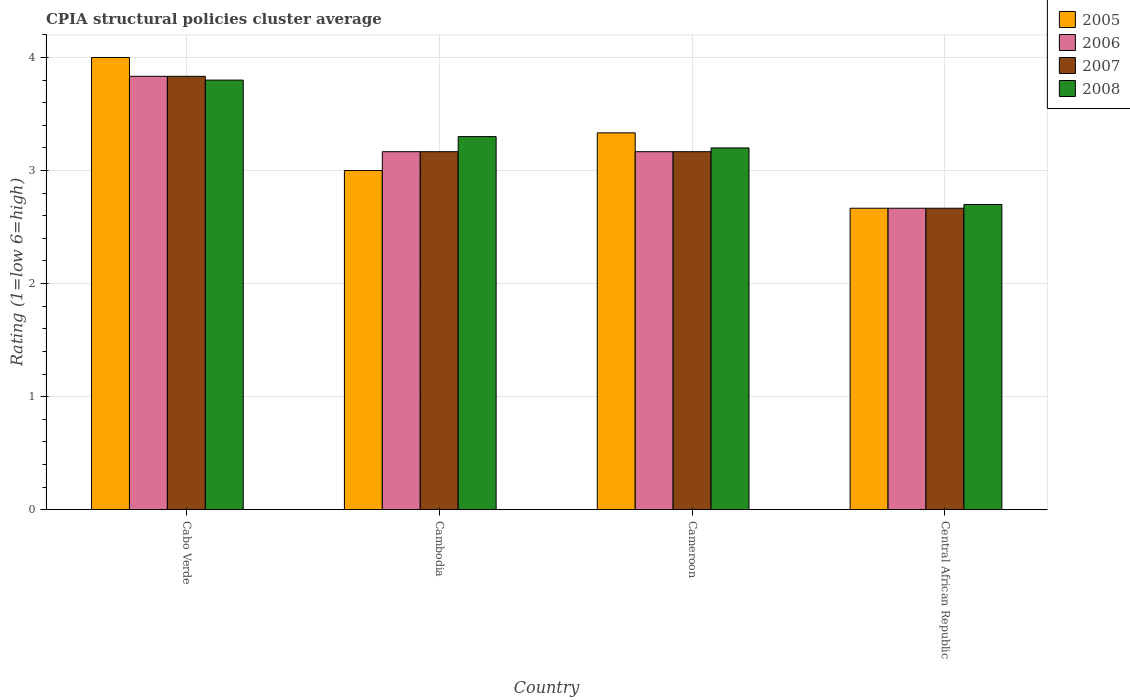Are the number of bars on each tick of the X-axis equal?
Keep it short and to the point. Yes. How many bars are there on the 4th tick from the left?
Give a very brief answer. 4. What is the label of the 3rd group of bars from the left?
Provide a short and direct response. Cameroon. In how many cases, is the number of bars for a given country not equal to the number of legend labels?
Your answer should be compact. 0. What is the CPIA rating in 2005 in Cameroon?
Your response must be concise. 3.33. Across all countries, what is the maximum CPIA rating in 2006?
Provide a succinct answer. 3.83. Across all countries, what is the minimum CPIA rating in 2007?
Give a very brief answer. 2.67. In which country was the CPIA rating in 2008 maximum?
Your response must be concise. Cabo Verde. In which country was the CPIA rating in 2008 minimum?
Make the answer very short. Central African Republic. What is the total CPIA rating in 2008 in the graph?
Your answer should be very brief. 13. What is the difference between the CPIA rating in 2005 in Central African Republic and the CPIA rating in 2006 in Cameroon?
Your answer should be compact. -0.5. What is the average CPIA rating in 2006 per country?
Offer a very short reply. 3.21. What is the difference between the CPIA rating of/in 2005 and CPIA rating of/in 2008 in Cameroon?
Your response must be concise. 0.13. In how many countries, is the CPIA rating in 2008 greater than 3.4?
Your answer should be very brief. 1. What is the ratio of the CPIA rating in 2006 in Cabo Verde to that in Cameroon?
Your response must be concise. 1.21. Is the CPIA rating in 2006 in Cabo Verde less than that in Cameroon?
Provide a short and direct response. No. Is the difference between the CPIA rating in 2005 in Cabo Verde and Cambodia greater than the difference between the CPIA rating in 2008 in Cabo Verde and Cambodia?
Your answer should be compact. Yes. What is the difference between the highest and the second highest CPIA rating in 2007?
Provide a short and direct response. -0.67. What is the difference between the highest and the lowest CPIA rating in 2008?
Keep it short and to the point. 1.1. Is the sum of the CPIA rating in 2006 in Cameroon and Central African Republic greater than the maximum CPIA rating in 2007 across all countries?
Your answer should be very brief. Yes. Is it the case that in every country, the sum of the CPIA rating in 2008 and CPIA rating in 2007 is greater than the sum of CPIA rating in 2005 and CPIA rating in 2006?
Your answer should be compact. No. How many countries are there in the graph?
Offer a terse response. 4. What is the difference between two consecutive major ticks on the Y-axis?
Your response must be concise. 1. Does the graph contain grids?
Offer a terse response. Yes. Where does the legend appear in the graph?
Provide a short and direct response. Top right. How are the legend labels stacked?
Provide a succinct answer. Vertical. What is the title of the graph?
Offer a very short reply. CPIA structural policies cluster average. Does "2005" appear as one of the legend labels in the graph?
Make the answer very short. Yes. What is the label or title of the X-axis?
Offer a very short reply. Country. What is the label or title of the Y-axis?
Ensure brevity in your answer.  Rating (1=low 6=high). What is the Rating (1=low 6=high) in 2005 in Cabo Verde?
Provide a succinct answer. 4. What is the Rating (1=low 6=high) in 2006 in Cabo Verde?
Your answer should be very brief. 3.83. What is the Rating (1=low 6=high) of 2007 in Cabo Verde?
Make the answer very short. 3.83. What is the Rating (1=low 6=high) in 2006 in Cambodia?
Give a very brief answer. 3.17. What is the Rating (1=low 6=high) of 2007 in Cambodia?
Provide a succinct answer. 3.17. What is the Rating (1=low 6=high) in 2005 in Cameroon?
Make the answer very short. 3.33. What is the Rating (1=low 6=high) of 2006 in Cameroon?
Your answer should be very brief. 3.17. What is the Rating (1=low 6=high) of 2007 in Cameroon?
Ensure brevity in your answer.  3.17. What is the Rating (1=low 6=high) of 2005 in Central African Republic?
Offer a very short reply. 2.67. What is the Rating (1=low 6=high) in 2006 in Central African Republic?
Provide a short and direct response. 2.67. What is the Rating (1=low 6=high) in 2007 in Central African Republic?
Offer a terse response. 2.67. Across all countries, what is the maximum Rating (1=low 6=high) in 2005?
Make the answer very short. 4. Across all countries, what is the maximum Rating (1=low 6=high) in 2006?
Provide a short and direct response. 3.83. Across all countries, what is the maximum Rating (1=low 6=high) in 2007?
Offer a terse response. 3.83. Across all countries, what is the maximum Rating (1=low 6=high) of 2008?
Make the answer very short. 3.8. Across all countries, what is the minimum Rating (1=low 6=high) of 2005?
Make the answer very short. 2.67. Across all countries, what is the minimum Rating (1=low 6=high) in 2006?
Offer a terse response. 2.67. Across all countries, what is the minimum Rating (1=low 6=high) in 2007?
Your answer should be very brief. 2.67. What is the total Rating (1=low 6=high) in 2005 in the graph?
Your answer should be compact. 13. What is the total Rating (1=low 6=high) in 2006 in the graph?
Give a very brief answer. 12.83. What is the total Rating (1=low 6=high) of 2007 in the graph?
Your answer should be compact. 12.83. What is the total Rating (1=low 6=high) in 2008 in the graph?
Offer a very short reply. 13. What is the difference between the Rating (1=low 6=high) of 2005 in Cabo Verde and that in Cambodia?
Keep it short and to the point. 1. What is the difference between the Rating (1=low 6=high) of 2006 in Cabo Verde and that in Cambodia?
Keep it short and to the point. 0.67. What is the difference between the Rating (1=low 6=high) in 2007 in Cabo Verde and that in Cambodia?
Provide a succinct answer. 0.67. What is the difference between the Rating (1=low 6=high) in 2006 in Cabo Verde and that in Cameroon?
Your response must be concise. 0.67. What is the difference between the Rating (1=low 6=high) in 2007 in Cabo Verde and that in Cameroon?
Keep it short and to the point. 0.67. What is the difference between the Rating (1=low 6=high) in 2005 in Cabo Verde and that in Central African Republic?
Your answer should be compact. 1.33. What is the difference between the Rating (1=low 6=high) of 2007 in Cabo Verde and that in Central African Republic?
Keep it short and to the point. 1.17. What is the difference between the Rating (1=low 6=high) of 2008 in Cabo Verde and that in Central African Republic?
Ensure brevity in your answer.  1.1. What is the difference between the Rating (1=low 6=high) in 2007 in Cambodia and that in Cameroon?
Ensure brevity in your answer.  0. What is the difference between the Rating (1=low 6=high) in 2005 in Cambodia and that in Central African Republic?
Offer a very short reply. 0.33. What is the difference between the Rating (1=low 6=high) of 2006 in Cambodia and that in Central African Republic?
Keep it short and to the point. 0.5. What is the difference between the Rating (1=low 6=high) in 2008 in Cambodia and that in Central African Republic?
Make the answer very short. 0.6. What is the difference between the Rating (1=low 6=high) in 2005 in Cameroon and that in Central African Republic?
Your answer should be very brief. 0.67. What is the difference between the Rating (1=low 6=high) in 2006 in Cameroon and that in Central African Republic?
Provide a short and direct response. 0.5. What is the difference between the Rating (1=low 6=high) of 2008 in Cameroon and that in Central African Republic?
Your answer should be very brief. 0.5. What is the difference between the Rating (1=low 6=high) in 2005 in Cabo Verde and the Rating (1=low 6=high) in 2008 in Cambodia?
Offer a terse response. 0.7. What is the difference between the Rating (1=low 6=high) in 2006 in Cabo Verde and the Rating (1=low 6=high) in 2007 in Cambodia?
Ensure brevity in your answer.  0.67. What is the difference between the Rating (1=low 6=high) of 2006 in Cabo Verde and the Rating (1=low 6=high) of 2008 in Cambodia?
Give a very brief answer. 0.53. What is the difference between the Rating (1=low 6=high) in 2007 in Cabo Verde and the Rating (1=low 6=high) in 2008 in Cambodia?
Keep it short and to the point. 0.53. What is the difference between the Rating (1=low 6=high) of 2005 in Cabo Verde and the Rating (1=low 6=high) of 2006 in Cameroon?
Your response must be concise. 0.83. What is the difference between the Rating (1=low 6=high) in 2005 in Cabo Verde and the Rating (1=low 6=high) in 2007 in Cameroon?
Offer a terse response. 0.83. What is the difference between the Rating (1=low 6=high) of 2005 in Cabo Verde and the Rating (1=low 6=high) of 2008 in Cameroon?
Keep it short and to the point. 0.8. What is the difference between the Rating (1=low 6=high) of 2006 in Cabo Verde and the Rating (1=low 6=high) of 2007 in Cameroon?
Offer a very short reply. 0.67. What is the difference between the Rating (1=low 6=high) in 2006 in Cabo Verde and the Rating (1=low 6=high) in 2008 in Cameroon?
Your answer should be very brief. 0.63. What is the difference between the Rating (1=low 6=high) of 2007 in Cabo Verde and the Rating (1=low 6=high) of 2008 in Cameroon?
Your response must be concise. 0.63. What is the difference between the Rating (1=low 6=high) of 2005 in Cabo Verde and the Rating (1=low 6=high) of 2006 in Central African Republic?
Offer a very short reply. 1.33. What is the difference between the Rating (1=low 6=high) in 2006 in Cabo Verde and the Rating (1=low 6=high) in 2007 in Central African Republic?
Make the answer very short. 1.17. What is the difference between the Rating (1=low 6=high) in 2006 in Cabo Verde and the Rating (1=low 6=high) in 2008 in Central African Republic?
Keep it short and to the point. 1.13. What is the difference between the Rating (1=low 6=high) of 2007 in Cabo Verde and the Rating (1=low 6=high) of 2008 in Central African Republic?
Give a very brief answer. 1.13. What is the difference between the Rating (1=low 6=high) in 2005 in Cambodia and the Rating (1=low 6=high) in 2006 in Cameroon?
Your response must be concise. -0.17. What is the difference between the Rating (1=low 6=high) in 2005 in Cambodia and the Rating (1=low 6=high) in 2008 in Cameroon?
Provide a succinct answer. -0.2. What is the difference between the Rating (1=low 6=high) in 2006 in Cambodia and the Rating (1=low 6=high) in 2007 in Cameroon?
Your answer should be compact. 0. What is the difference between the Rating (1=low 6=high) of 2006 in Cambodia and the Rating (1=low 6=high) of 2008 in Cameroon?
Ensure brevity in your answer.  -0.03. What is the difference between the Rating (1=low 6=high) of 2007 in Cambodia and the Rating (1=low 6=high) of 2008 in Cameroon?
Make the answer very short. -0.03. What is the difference between the Rating (1=low 6=high) of 2005 in Cambodia and the Rating (1=low 6=high) of 2006 in Central African Republic?
Provide a succinct answer. 0.33. What is the difference between the Rating (1=low 6=high) in 2006 in Cambodia and the Rating (1=low 6=high) in 2008 in Central African Republic?
Your answer should be very brief. 0.47. What is the difference between the Rating (1=low 6=high) of 2007 in Cambodia and the Rating (1=low 6=high) of 2008 in Central African Republic?
Provide a short and direct response. 0.47. What is the difference between the Rating (1=low 6=high) of 2005 in Cameroon and the Rating (1=low 6=high) of 2007 in Central African Republic?
Offer a very short reply. 0.67. What is the difference between the Rating (1=low 6=high) in 2005 in Cameroon and the Rating (1=low 6=high) in 2008 in Central African Republic?
Provide a succinct answer. 0.63. What is the difference between the Rating (1=low 6=high) of 2006 in Cameroon and the Rating (1=low 6=high) of 2007 in Central African Republic?
Your response must be concise. 0.5. What is the difference between the Rating (1=low 6=high) of 2006 in Cameroon and the Rating (1=low 6=high) of 2008 in Central African Republic?
Make the answer very short. 0.47. What is the difference between the Rating (1=low 6=high) of 2007 in Cameroon and the Rating (1=low 6=high) of 2008 in Central African Republic?
Keep it short and to the point. 0.47. What is the average Rating (1=low 6=high) in 2005 per country?
Provide a short and direct response. 3.25. What is the average Rating (1=low 6=high) of 2006 per country?
Ensure brevity in your answer.  3.21. What is the average Rating (1=low 6=high) in 2007 per country?
Ensure brevity in your answer.  3.21. What is the average Rating (1=low 6=high) of 2008 per country?
Offer a very short reply. 3.25. What is the difference between the Rating (1=low 6=high) of 2005 and Rating (1=low 6=high) of 2006 in Cabo Verde?
Offer a terse response. 0.17. What is the difference between the Rating (1=low 6=high) in 2005 and Rating (1=low 6=high) in 2008 in Cabo Verde?
Keep it short and to the point. 0.2. What is the difference between the Rating (1=low 6=high) in 2006 and Rating (1=low 6=high) in 2007 in Cabo Verde?
Your response must be concise. 0. What is the difference between the Rating (1=low 6=high) of 2006 and Rating (1=low 6=high) of 2008 in Cabo Verde?
Offer a terse response. 0.03. What is the difference between the Rating (1=low 6=high) in 2006 and Rating (1=low 6=high) in 2008 in Cambodia?
Make the answer very short. -0.13. What is the difference between the Rating (1=low 6=high) of 2007 and Rating (1=low 6=high) of 2008 in Cambodia?
Your answer should be compact. -0.13. What is the difference between the Rating (1=low 6=high) of 2005 and Rating (1=low 6=high) of 2007 in Cameroon?
Your response must be concise. 0.17. What is the difference between the Rating (1=low 6=high) of 2005 and Rating (1=low 6=high) of 2008 in Cameroon?
Give a very brief answer. 0.13. What is the difference between the Rating (1=low 6=high) in 2006 and Rating (1=low 6=high) in 2008 in Cameroon?
Provide a succinct answer. -0.03. What is the difference between the Rating (1=low 6=high) of 2007 and Rating (1=low 6=high) of 2008 in Cameroon?
Provide a succinct answer. -0.03. What is the difference between the Rating (1=low 6=high) of 2005 and Rating (1=low 6=high) of 2006 in Central African Republic?
Make the answer very short. 0. What is the difference between the Rating (1=low 6=high) in 2005 and Rating (1=low 6=high) in 2008 in Central African Republic?
Provide a succinct answer. -0.03. What is the difference between the Rating (1=low 6=high) in 2006 and Rating (1=low 6=high) in 2007 in Central African Republic?
Your answer should be compact. 0. What is the difference between the Rating (1=low 6=high) of 2006 and Rating (1=low 6=high) of 2008 in Central African Republic?
Your answer should be very brief. -0.03. What is the difference between the Rating (1=low 6=high) in 2007 and Rating (1=low 6=high) in 2008 in Central African Republic?
Provide a succinct answer. -0.03. What is the ratio of the Rating (1=low 6=high) of 2005 in Cabo Verde to that in Cambodia?
Offer a terse response. 1.33. What is the ratio of the Rating (1=low 6=high) in 2006 in Cabo Verde to that in Cambodia?
Your response must be concise. 1.21. What is the ratio of the Rating (1=low 6=high) of 2007 in Cabo Verde to that in Cambodia?
Provide a succinct answer. 1.21. What is the ratio of the Rating (1=low 6=high) in 2008 in Cabo Verde to that in Cambodia?
Offer a very short reply. 1.15. What is the ratio of the Rating (1=low 6=high) in 2006 in Cabo Verde to that in Cameroon?
Your answer should be very brief. 1.21. What is the ratio of the Rating (1=low 6=high) of 2007 in Cabo Verde to that in Cameroon?
Provide a succinct answer. 1.21. What is the ratio of the Rating (1=low 6=high) of 2008 in Cabo Verde to that in Cameroon?
Provide a short and direct response. 1.19. What is the ratio of the Rating (1=low 6=high) in 2006 in Cabo Verde to that in Central African Republic?
Your answer should be very brief. 1.44. What is the ratio of the Rating (1=low 6=high) in 2007 in Cabo Verde to that in Central African Republic?
Your response must be concise. 1.44. What is the ratio of the Rating (1=low 6=high) in 2008 in Cabo Verde to that in Central African Republic?
Give a very brief answer. 1.41. What is the ratio of the Rating (1=low 6=high) in 2005 in Cambodia to that in Cameroon?
Offer a very short reply. 0.9. What is the ratio of the Rating (1=low 6=high) of 2007 in Cambodia to that in Cameroon?
Provide a short and direct response. 1. What is the ratio of the Rating (1=low 6=high) of 2008 in Cambodia to that in Cameroon?
Offer a very short reply. 1.03. What is the ratio of the Rating (1=low 6=high) of 2005 in Cambodia to that in Central African Republic?
Your answer should be compact. 1.12. What is the ratio of the Rating (1=low 6=high) of 2006 in Cambodia to that in Central African Republic?
Provide a short and direct response. 1.19. What is the ratio of the Rating (1=low 6=high) of 2007 in Cambodia to that in Central African Republic?
Provide a succinct answer. 1.19. What is the ratio of the Rating (1=low 6=high) in 2008 in Cambodia to that in Central African Republic?
Make the answer very short. 1.22. What is the ratio of the Rating (1=low 6=high) in 2005 in Cameroon to that in Central African Republic?
Offer a very short reply. 1.25. What is the ratio of the Rating (1=low 6=high) in 2006 in Cameroon to that in Central African Republic?
Make the answer very short. 1.19. What is the ratio of the Rating (1=low 6=high) in 2007 in Cameroon to that in Central African Republic?
Provide a succinct answer. 1.19. What is the ratio of the Rating (1=low 6=high) in 2008 in Cameroon to that in Central African Republic?
Offer a terse response. 1.19. What is the difference between the highest and the second highest Rating (1=low 6=high) of 2005?
Offer a terse response. 0.67. What is the difference between the highest and the second highest Rating (1=low 6=high) in 2006?
Provide a succinct answer. 0.67. What is the difference between the highest and the lowest Rating (1=low 6=high) in 2006?
Ensure brevity in your answer.  1.17. What is the difference between the highest and the lowest Rating (1=low 6=high) in 2007?
Your answer should be compact. 1.17. What is the difference between the highest and the lowest Rating (1=low 6=high) in 2008?
Offer a terse response. 1.1. 